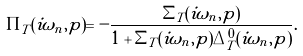Convert formula to latex. <formula><loc_0><loc_0><loc_500><loc_500>\Pi _ { T } ( i \omega _ { n } , p ) = - \frac { \Sigma _ { T } ( i \omega _ { n } , p ) } { 1 + \Sigma _ { T } ( i \omega _ { n } , p ) \Delta _ { T } ^ { 0 } ( i \omega _ { n } , p ) } .</formula> 